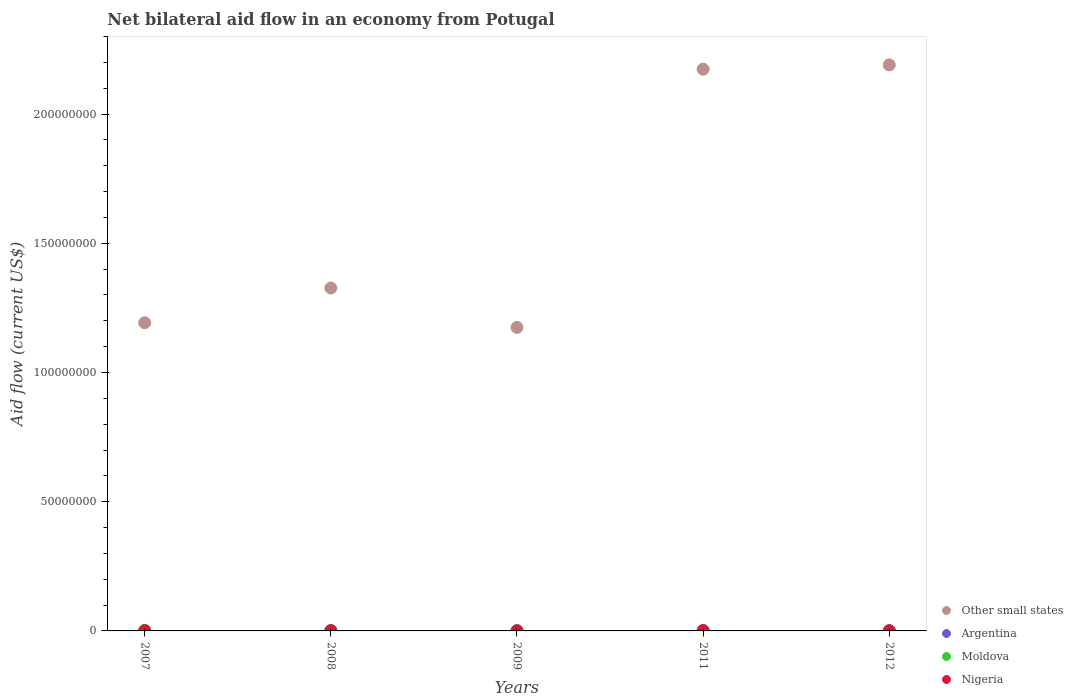Is the number of dotlines equal to the number of legend labels?
Provide a succinct answer. Yes. What is the net bilateral aid flow in Other small states in 2008?
Provide a succinct answer. 1.33e+08. In which year was the net bilateral aid flow in Moldova maximum?
Provide a short and direct response. 2007. In which year was the net bilateral aid flow in Nigeria minimum?
Keep it short and to the point. 2009. What is the total net bilateral aid flow in Moldova in the graph?
Your response must be concise. 2.70e+05. What is the difference between the net bilateral aid flow in Nigeria in 2009 and the net bilateral aid flow in Other small states in 2012?
Ensure brevity in your answer.  -2.19e+08. What is the average net bilateral aid flow in Nigeria per year?
Offer a terse response. 7.20e+04. In the year 2008, what is the difference between the net bilateral aid flow in Nigeria and net bilateral aid flow in Other small states?
Keep it short and to the point. -1.33e+08. In how many years, is the net bilateral aid flow in Other small states greater than 150000000 US$?
Make the answer very short. 2. What is the ratio of the net bilateral aid flow in Nigeria in 2009 to that in 2011?
Provide a short and direct response. 0.36. Is the net bilateral aid flow in Nigeria in 2007 less than that in 2012?
Make the answer very short. No. What is the difference between the highest and the lowest net bilateral aid flow in Other small states?
Provide a succinct answer. 1.02e+08. Is it the case that in every year, the sum of the net bilateral aid flow in Other small states and net bilateral aid flow in Moldova  is greater than the net bilateral aid flow in Nigeria?
Your answer should be very brief. Yes. How many dotlines are there?
Provide a succinct answer. 4. Are the values on the major ticks of Y-axis written in scientific E-notation?
Your response must be concise. No. Does the graph contain any zero values?
Your response must be concise. No. Where does the legend appear in the graph?
Make the answer very short. Bottom right. What is the title of the graph?
Keep it short and to the point. Net bilateral aid flow in an economy from Potugal. What is the label or title of the X-axis?
Give a very brief answer. Years. What is the label or title of the Y-axis?
Give a very brief answer. Aid flow (current US$). What is the Aid flow (current US$) in Other small states in 2007?
Provide a short and direct response. 1.19e+08. What is the Aid flow (current US$) in Other small states in 2008?
Keep it short and to the point. 1.33e+08. What is the Aid flow (current US$) in Argentina in 2008?
Ensure brevity in your answer.  1.20e+05. What is the Aid flow (current US$) of Moldova in 2008?
Your answer should be compact. 10000. What is the Aid flow (current US$) in Nigeria in 2008?
Ensure brevity in your answer.  8.00e+04. What is the Aid flow (current US$) of Other small states in 2009?
Make the answer very short. 1.17e+08. What is the Aid flow (current US$) of Moldova in 2009?
Keep it short and to the point. 10000. What is the Aid flow (current US$) of Nigeria in 2009?
Provide a succinct answer. 4.00e+04. What is the Aid flow (current US$) in Other small states in 2011?
Provide a succinct answer. 2.17e+08. What is the Aid flow (current US$) in Argentina in 2011?
Offer a very short reply. 1.00e+05. What is the Aid flow (current US$) in Nigeria in 2011?
Your answer should be compact. 1.10e+05. What is the Aid flow (current US$) of Other small states in 2012?
Your answer should be very brief. 2.19e+08. What is the Aid flow (current US$) of Nigeria in 2012?
Give a very brief answer. 6.00e+04. Across all years, what is the maximum Aid flow (current US$) in Other small states?
Offer a terse response. 2.19e+08. Across all years, what is the maximum Aid flow (current US$) of Moldova?
Provide a short and direct response. 2.20e+05. Across all years, what is the minimum Aid flow (current US$) of Other small states?
Keep it short and to the point. 1.17e+08. Across all years, what is the minimum Aid flow (current US$) of Argentina?
Keep it short and to the point. 8.00e+04. Across all years, what is the minimum Aid flow (current US$) of Moldova?
Ensure brevity in your answer.  10000. Across all years, what is the minimum Aid flow (current US$) of Nigeria?
Ensure brevity in your answer.  4.00e+04. What is the total Aid flow (current US$) in Other small states in the graph?
Your answer should be very brief. 8.06e+08. What is the total Aid flow (current US$) of Argentina in the graph?
Provide a short and direct response. 5.30e+05. What is the total Aid flow (current US$) of Moldova in the graph?
Provide a short and direct response. 2.70e+05. What is the total Aid flow (current US$) in Nigeria in the graph?
Ensure brevity in your answer.  3.60e+05. What is the difference between the Aid flow (current US$) in Other small states in 2007 and that in 2008?
Provide a short and direct response. -1.34e+07. What is the difference between the Aid flow (current US$) in Moldova in 2007 and that in 2008?
Ensure brevity in your answer.  2.10e+05. What is the difference between the Aid flow (current US$) of Nigeria in 2007 and that in 2008?
Ensure brevity in your answer.  -10000. What is the difference between the Aid flow (current US$) in Other small states in 2007 and that in 2009?
Make the answer very short. 1.80e+06. What is the difference between the Aid flow (current US$) in Nigeria in 2007 and that in 2009?
Provide a short and direct response. 3.00e+04. What is the difference between the Aid flow (current US$) in Other small states in 2007 and that in 2011?
Provide a short and direct response. -9.81e+07. What is the difference between the Aid flow (current US$) in Argentina in 2007 and that in 2011?
Keep it short and to the point. 4.00e+04. What is the difference between the Aid flow (current US$) in Moldova in 2007 and that in 2011?
Ensure brevity in your answer.  2.10e+05. What is the difference between the Aid flow (current US$) in Nigeria in 2007 and that in 2011?
Provide a succinct answer. -4.00e+04. What is the difference between the Aid flow (current US$) in Other small states in 2007 and that in 2012?
Give a very brief answer. -9.98e+07. What is the difference between the Aid flow (current US$) of Moldova in 2007 and that in 2012?
Provide a succinct answer. 2.00e+05. What is the difference between the Aid flow (current US$) in Other small states in 2008 and that in 2009?
Provide a short and direct response. 1.52e+07. What is the difference between the Aid flow (current US$) in Argentina in 2008 and that in 2009?
Your answer should be compact. 3.00e+04. What is the difference between the Aid flow (current US$) in Other small states in 2008 and that in 2011?
Offer a terse response. -8.47e+07. What is the difference between the Aid flow (current US$) in Argentina in 2008 and that in 2011?
Your answer should be compact. 2.00e+04. What is the difference between the Aid flow (current US$) in Moldova in 2008 and that in 2011?
Provide a succinct answer. 0. What is the difference between the Aid flow (current US$) in Nigeria in 2008 and that in 2011?
Keep it short and to the point. -3.00e+04. What is the difference between the Aid flow (current US$) in Other small states in 2008 and that in 2012?
Your answer should be very brief. -8.64e+07. What is the difference between the Aid flow (current US$) of Nigeria in 2008 and that in 2012?
Ensure brevity in your answer.  2.00e+04. What is the difference between the Aid flow (current US$) of Other small states in 2009 and that in 2011?
Your response must be concise. -9.99e+07. What is the difference between the Aid flow (current US$) in Moldova in 2009 and that in 2011?
Keep it short and to the point. 0. What is the difference between the Aid flow (current US$) of Nigeria in 2009 and that in 2011?
Your answer should be very brief. -7.00e+04. What is the difference between the Aid flow (current US$) of Other small states in 2009 and that in 2012?
Provide a succinct answer. -1.02e+08. What is the difference between the Aid flow (current US$) of Other small states in 2011 and that in 2012?
Make the answer very short. -1.66e+06. What is the difference between the Aid flow (current US$) in Nigeria in 2011 and that in 2012?
Make the answer very short. 5.00e+04. What is the difference between the Aid flow (current US$) of Other small states in 2007 and the Aid flow (current US$) of Argentina in 2008?
Your answer should be compact. 1.19e+08. What is the difference between the Aid flow (current US$) of Other small states in 2007 and the Aid flow (current US$) of Moldova in 2008?
Your response must be concise. 1.19e+08. What is the difference between the Aid flow (current US$) of Other small states in 2007 and the Aid flow (current US$) of Nigeria in 2008?
Keep it short and to the point. 1.19e+08. What is the difference between the Aid flow (current US$) of Moldova in 2007 and the Aid flow (current US$) of Nigeria in 2008?
Keep it short and to the point. 1.40e+05. What is the difference between the Aid flow (current US$) of Other small states in 2007 and the Aid flow (current US$) of Argentina in 2009?
Your response must be concise. 1.19e+08. What is the difference between the Aid flow (current US$) in Other small states in 2007 and the Aid flow (current US$) in Moldova in 2009?
Ensure brevity in your answer.  1.19e+08. What is the difference between the Aid flow (current US$) of Other small states in 2007 and the Aid flow (current US$) of Nigeria in 2009?
Provide a succinct answer. 1.19e+08. What is the difference between the Aid flow (current US$) in Other small states in 2007 and the Aid flow (current US$) in Argentina in 2011?
Your response must be concise. 1.19e+08. What is the difference between the Aid flow (current US$) of Other small states in 2007 and the Aid flow (current US$) of Moldova in 2011?
Make the answer very short. 1.19e+08. What is the difference between the Aid flow (current US$) in Other small states in 2007 and the Aid flow (current US$) in Nigeria in 2011?
Ensure brevity in your answer.  1.19e+08. What is the difference between the Aid flow (current US$) of Other small states in 2007 and the Aid flow (current US$) of Argentina in 2012?
Your answer should be very brief. 1.19e+08. What is the difference between the Aid flow (current US$) in Other small states in 2007 and the Aid flow (current US$) in Moldova in 2012?
Your response must be concise. 1.19e+08. What is the difference between the Aid flow (current US$) in Other small states in 2007 and the Aid flow (current US$) in Nigeria in 2012?
Provide a short and direct response. 1.19e+08. What is the difference between the Aid flow (current US$) of Argentina in 2007 and the Aid flow (current US$) of Moldova in 2012?
Make the answer very short. 1.20e+05. What is the difference between the Aid flow (current US$) in Other small states in 2008 and the Aid flow (current US$) in Argentina in 2009?
Provide a succinct answer. 1.33e+08. What is the difference between the Aid flow (current US$) of Other small states in 2008 and the Aid flow (current US$) of Moldova in 2009?
Your response must be concise. 1.33e+08. What is the difference between the Aid flow (current US$) of Other small states in 2008 and the Aid flow (current US$) of Nigeria in 2009?
Provide a short and direct response. 1.33e+08. What is the difference between the Aid flow (current US$) in Argentina in 2008 and the Aid flow (current US$) in Nigeria in 2009?
Your answer should be very brief. 8.00e+04. What is the difference between the Aid flow (current US$) in Moldova in 2008 and the Aid flow (current US$) in Nigeria in 2009?
Ensure brevity in your answer.  -3.00e+04. What is the difference between the Aid flow (current US$) of Other small states in 2008 and the Aid flow (current US$) of Argentina in 2011?
Provide a succinct answer. 1.33e+08. What is the difference between the Aid flow (current US$) of Other small states in 2008 and the Aid flow (current US$) of Moldova in 2011?
Ensure brevity in your answer.  1.33e+08. What is the difference between the Aid flow (current US$) in Other small states in 2008 and the Aid flow (current US$) in Nigeria in 2011?
Offer a very short reply. 1.33e+08. What is the difference between the Aid flow (current US$) in Argentina in 2008 and the Aid flow (current US$) in Moldova in 2011?
Keep it short and to the point. 1.10e+05. What is the difference between the Aid flow (current US$) in Argentina in 2008 and the Aid flow (current US$) in Nigeria in 2011?
Provide a short and direct response. 10000. What is the difference between the Aid flow (current US$) of Moldova in 2008 and the Aid flow (current US$) of Nigeria in 2011?
Give a very brief answer. -1.00e+05. What is the difference between the Aid flow (current US$) in Other small states in 2008 and the Aid flow (current US$) in Argentina in 2012?
Your answer should be very brief. 1.33e+08. What is the difference between the Aid flow (current US$) in Other small states in 2008 and the Aid flow (current US$) in Moldova in 2012?
Ensure brevity in your answer.  1.33e+08. What is the difference between the Aid flow (current US$) in Other small states in 2008 and the Aid flow (current US$) in Nigeria in 2012?
Offer a terse response. 1.33e+08. What is the difference between the Aid flow (current US$) in Other small states in 2009 and the Aid flow (current US$) in Argentina in 2011?
Your answer should be compact. 1.17e+08. What is the difference between the Aid flow (current US$) of Other small states in 2009 and the Aid flow (current US$) of Moldova in 2011?
Make the answer very short. 1.17e+08. What is the difference between the Aid flow (current US$) of Other small states in 2009 and the Aid flow (current US$) of Nigeria in 2011?
Your response must be concise. 1.17e+08. What is the difference between the Aid flow (current US$) in Other small states in 2009 and the Aid flow (current US$) in Argentina in 2012?
Make the answer very short. 1.17e+08. What is the difference between the Aid flow (current US$) of Other small states in 2009 and the Aid flow (current US$) of Moldova in 2012?
Your answer should be compact. 1.17e+08. What is the difference between the Aid flow (current US$) in Other small states in 2009 and the Aid flow (current US$) in Nigeria in 2012?
Provide a succinct answer. 1.17e+08. What is the difference between the Aid flow (current US$) in Other small states in 2011 and the Aid flow (current US$) in Argentina in 2012?
Ensure brevity in your answer.  2.17e+08. What is the difference between the Aid flow (current US$) of Other small states in 2011 and the Aid flow (current US$) of Moldova in 2012?
Provide a succinct answer. 2.17e+08. What is the difference between the Aid flow (current US$) in Other small states in 2011 and the Aid flow (current US$) in Nigeria in 2012?
Your answer should be compact. 2.17e+08. What is the difference between the Aid flow (current US$) in Argentina in 2011 and the Aid flow (current US$) in Moldova in 2012?
Your response must be concise. 8.00e+04. What is the difference between the Aid flow (current US$) in Argentina in 2011 and the Aid flow (current US$) in Nigeria in 2012?
Offer a terse response. 4.00e+04. What is the difference between the Aid flow (current US$) in Moldova in 2011 and the Aid flow (current US$) in Nigeria in 2012?
Your answer should be compact. -5.00e+04. What is the average Aid flow (current US$) in Other small states per year?
Keep it short and to the point. 1.61e+08. What is the average Aid flow (current US$) in Argentina per year?
Ensure brevity in your answer.  1.06e+05. What is the average Aid flow (current US$) in Moldova per year?
Give a very brief answer. 5.40e+04. What is the average Aid flow (current US$) in Nigeria per year?
Provide a succinct answer. 7.20e+04. In the year 2007, what is the difference between the Aid flow (current US$) in Other small states and Aid flow (current US$) in Argentina?
Provide a succinct answer. 1.19e+08. In the year 2007, what is the difference between the Aid flow (current US$) of Other small states and Aid flow (current US$) of Moldova?
Give a very brief answer. 1.19e+08. In the year 2007, what is the difference between the Aid flow (current US$) of Other small states and Aid flow (current US$) of Nigeria?
Offer a terse response. 1.19e+08. In the year 2007, what is the difference between the Aid flow (current US$) of Argentina and Aid flow (current US$) of Nigeria?
Your answer should be compact. 7.00e+04. In the year 2008, what is the difference between the Aid flow (current US$) in Other small states and Aid flow (current US$) in Argentina?
Provide a succinct answer. 1.33e+08. In the year 2008, what is the difference between the Aid flow (current US$) of Other small states and Aid flow (current US$) of Moldova?
Ensure brevity in your answer.  1.33e+08. In the year 2008, what is the difference between the Aid flow (current US$) in Other small states and Aid flow (current US$) in Nigeria?
Your response must be concise. 1.33e+08. In the year 2008, what is the difference between the Aid flow (current US$) of Argentina and Aid flow (current US$) of Nigeria?
Offer a very short reply. 4.00e+04. In the year 2008, what is the difference between the Aid flow (current US$) of Moldova and Aid flow (current US$) of Nigeria?
Provide a short and direct response. -7.00e+04. In the year 2009, what is the difference between the Aid flow (current US$) in Other small states and Aid flow (current US$) in Argentina?
Your answer should be compact. 1.17e+08. In the year 2009, what is the difference between the Aid flow (current US$) of Other small states and Aid flow (current US$) of Moldova?
Provide a succinct answer. 1.17e+08. In the year 2009, what is the difference between the Aid flow (current US$) in Other small states and Aid flow (current US$) in Nigeria?
Your response must be concise. 1.17e+08. In the year 2011, what is the difference between the Aid flow (current US$) of Other small states and Aid flow (current US$) of Argentina?
Offer a terse response. 2.17e+08. In the year 2011, what is the difference between the Aid flow (current US$) in Other small states and Aid flow (current US$) in Moldova?
Your answer should be compact. 2.17e+08. In the year 2011, what is the difference between the Aid flow (current US$) in Other small states and Aid flow (current US$) in Nigeria?
Provide a succinct answer. 2.17e+08. In the year 2012, what is the difference between the Aid flow (current US$) in Other small states and Aid flow (current US$) in Argentina?
Give a very brief answer. 2.19e+08. In the year 2012, what is the difference between the Aid flow (current US$) of Other small states and Aid flow (current US$) of Moldova?
Provide a succinct answer. 2.19e+08. In the year 2012, what is the difference between the Aid flow (current US$) in Other small states and Aid flow (current US$) in Nigeria?
Your response must be concise. 2.19e+08. In the year 2012, what is the difference between the Aid flow (current US$) in Argentina and Aid flow (current US$) in Nigeria?
Your answer should be compact. 2.00e+04. What is the ratio of the Aid flow (current US$) in Other small states in 2007 to that in 2008?
Offer a very short reply. 0.9. What is the ratio of the Aid flow (current US$) in Nigeria in 2007 to that in 2008?
Offer a terse response. 0.88. What is the ratio of the Aid flow (current US$) in Other small states in 2007 to that in 2009?
Offer a very short reply. 1.02. What is the ratio of the Aid flow (current US$) in Argentina in 2007 to that in 2009?
Provide a succinct answer. 1.56. What is the ratio of the Aid flow (current US$) of Moldova in 2007 to that in 2009?
Give a very brief answer. 22. What is the ratio of the Aid flow (current US$) of Other small states in 2007 to that in 2011?
Provide a succinct answer. 0.55. What is the ratio of the Aid flow (current US$) of Argentina in 2007 to that in 2011?
Ensure brevity in your answer.  1.4. What is the ratio of the Aid flow (current US$) of Nigeria in 2007 to that in 2011?
Offer a very short reply. 0.64. What is the ratio of the Aid flow (current US$) of Other small states in 2007 to that in 2012?
Offer a very short reply. 0.54. What is the ratio of the Aid flow (current US$) of Moldova in 2007 to that in 2012?
Provide a short and direct response. 11. What is the ratio of the Aid flow (current US$) of Other small states in 2008 to that in 2009?
Your response must be concise. 1.13. What is the ratio of the Aid flow (current US$) of Argentina in 2008 to that in 2009?
Provide a short and direct response. 1.33. What is the ratio of the Aid flow (current US$) of Other small states in 2008 to that in 2011?
Offer a very short reply. 0.61. What is the ratio of the Aid flow (current US$) in Nigeria in 2008 to that in 2011?
Make the answer very short. 0.73. What is the ratio of the Aid flow (current US$) in Other small states in 2008 to that in 2012?
Provide a succinct answer. 0.61. What is the ratio of the Aid flow (current US$) of Argentina in 2008 to that in 2012?
Make the answer very short. 1.5. What is the ratio of the Aid flow (current US$) of Nigeria in 2008 to that in 2012?
Offer a very short reply. 1.33. What is the ratio of the Aid flow (current US$) in Other small states in 2009 to that in 2011?
Make the answer very short. 0.54. What is the ratio of the Aid flow (current US$) of Argentina in 2009 to that in 2011?
Give a very brief answer. 0.9. What is the ratio of the Aid flow (current US$) of Moldova in 2009 to that in 2011?
Offer a terse response. 1. What is the ratio of the Aid flow (current US$) in Nigeria in 2009 to that in 2011?
Keep it short and to the point. 0.36. What is the ratio of the Aid flow (current US$) of Other small states in 2009 to that in 2012?
Keep it short and to the point. 0.54. What is the ratio of the Aid flow (current US$) of Argentina in 2009 to that in 2012?
Provide a short and direct response. 1.12. What is the ratio of the Aid flow (current US$) of Moldova in 2009 to that in 2012?
Offer a terse response. 0.5. What is the ratio of the Aid flow (current US$) in Nigeria in 2009 to that in 2012?
Offer a very short reply. 0.67. What is the ratio of the Aid flow (current US$) in Moldova in 2011 to that in 2012?
Keep it short and to the point. 0.5. What is the ratio of the Aid flow (current US$) of Nigeria in 2011 to that in 2012?
Make the answer very short. 1.83. What is the difference between the highest and the second highest Aid flow (current US$) of Other small states?
Offer a terse response. 1.66e+06. What is the difference between the highest and the second highest Aid flow (current US$) in Argentina?
Provide a short and direct response. 2.00e+04. What is the difference between the highest and the second highest Aid flow (current US$) of Moldova?
Keep it short and to the point. 2.00e+05. What is the difference between the highest and the second highest Aid flow (current US$) of Nigeria?
Offer a very short reply. 3.00e+04. What is the difference between the highest and the lowest Aid flow (current US$) of Other small states?
Give a very brief answer. 1.02e+08. 